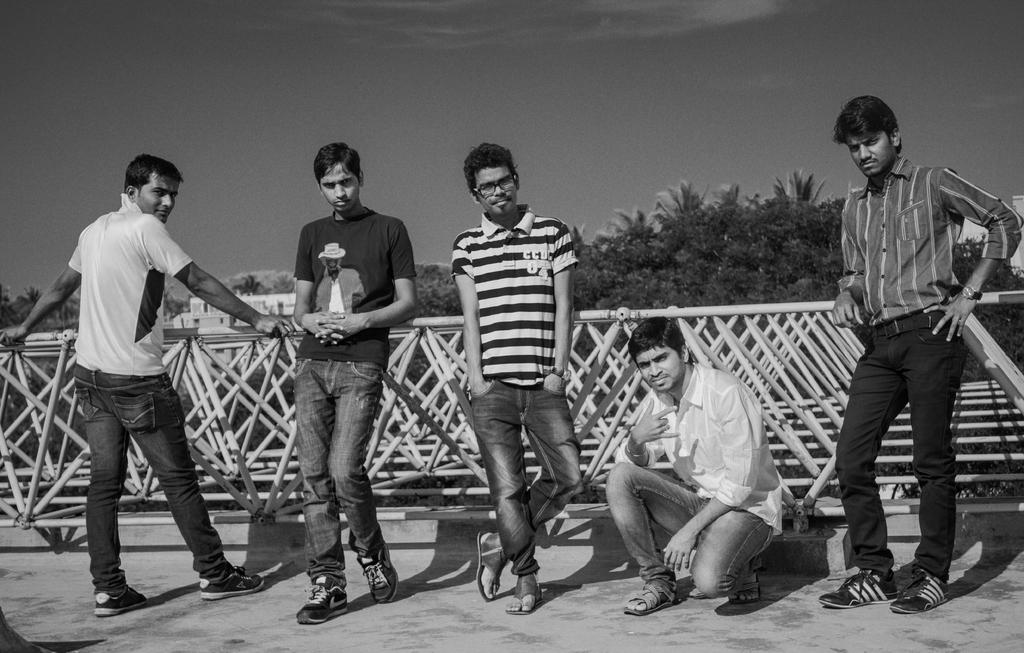What is the main subject of the image? The main subject of the image is a group of people on the ground. What can be seen in the background of the image? The sky is visible in the background of the image. Are there any structures or objects in the image? Yes, there is a fence in the image. What type of natural elements are present in the image? There are trees in the image. What type of wax can be seen melting on the fence in the image? There is no wax present in the image, so it cannot be determined if any wax is melting on the fence. 